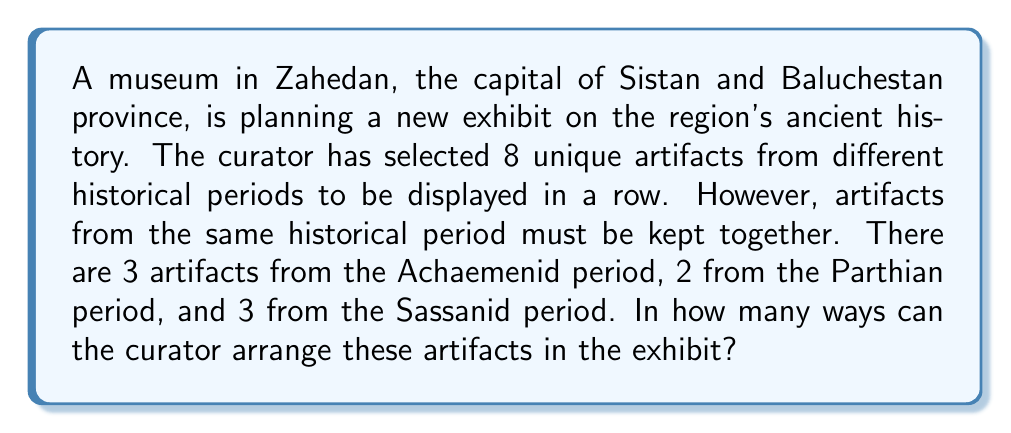Give your solution to this math problem. Let's approach this problem step by step:

1) First, we need to consider the artifacts from each period as a single unit. So, we essentially have 3 units to arrange (Achaemenid, Parthian, and Sassanid).

2) The number of ways to arrange these 3 units is simply 3! = 6.

3) Now, for each of these 6 arrangements, we need to consider the ways to arrange the artifacts within each period:

   - For the Achaemenid period (3 artifacts): 3! = 6 ways
   - For the Parthian period (2 artifacts): 2! = 2 ways
   - For the Sassanid period (3 artifacts): 3! = 6 ways

4) According to the multiplication principle, for each of the 6 arrangements of periods, we multiply the number of ways to arrange artifacts within each period:

   $6 \times 2 \times 6 = 72$

5) Finally, we multiply this by the number of ways to arrange the periods:

   $6 \times 72 = 432$

Therefore, the total number of ways to arrange the artifacts is 432.

This can be expressed mathematically as:

$$3! \times (3! \times 2! \times 3!) = 432$$

Where the outer 3! represents the arrangement of periods, and the inner multiplication represents the arrangements within each period.
Answer: 432 ways 